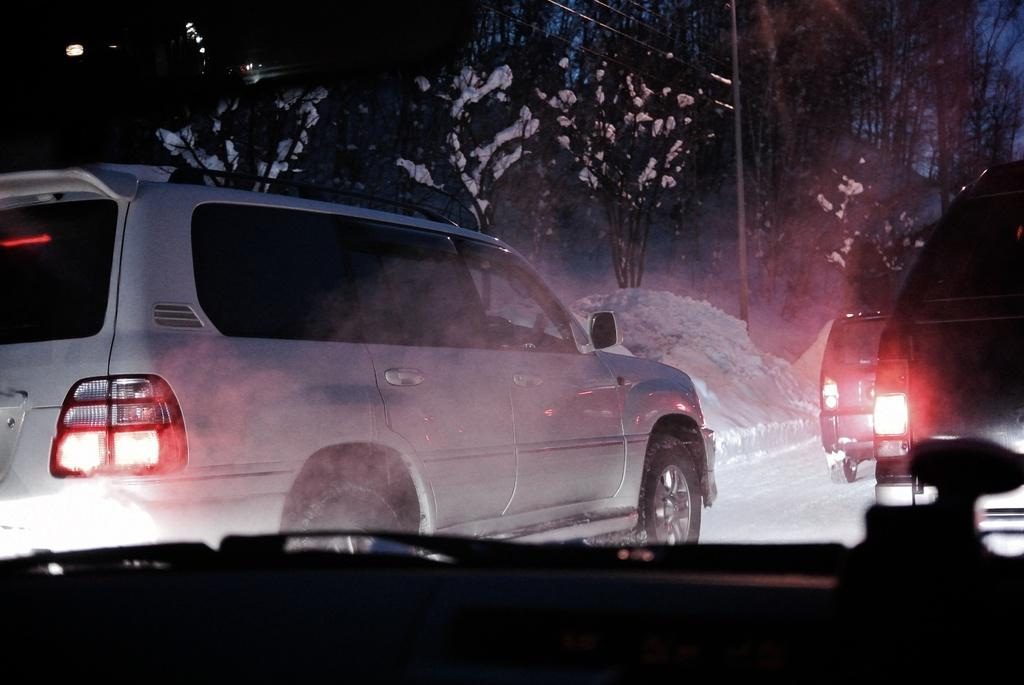What type of vehicles can be seen in the image? There are cars in the image. What is the weather condition in the image? There is snow in the image. What can be seen in the background of the image? There are trees and wires in the background of the image. What is visible in the sky in the image? The sky is visible in the background of the image. What type of care is being provided to the bomb in the image? There is no bomb present in the image; it only features cars, snow, trees, wires, and the sky. How is the cork being used in the image? There is no cork present in the image. 